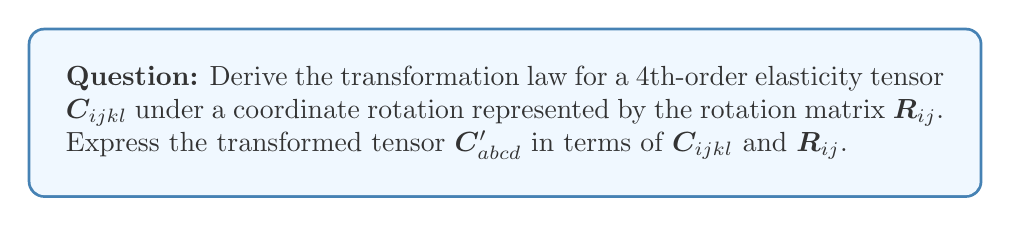What is the answer to this math problem? Let's approach this step-by-step:

1) First, recall that for a 4th-order tensor, the transformation law involves four rotation matrices:

   $$C'_{abcd} = R_{ai}R_{bj}R_{ck}R_{dl}C_{ijkl}$$

2) This equation represents the transformation of each index of the tensor. Each $R$ matrix rotates one index.

3) The summation convention is implied here, meaning we sum over repeated indices (i, j, k, l in this case).

4) To understand this transformation, let's break it down:
   - $R_{ai}$ rotates the first index (i to a)
   - $R_{bj}$ rotates the second index (j to b)
   - $R_{ck}$ rotates the third index (k to c)
   - $R_{dl}$ rotates the fourth index (l to d)

5) The rotation matrix $R_{ij}$ is orthogonal, meaning its inverse is equal to its transpose:

   $$R_{ij}^{-1} = R_{ji}$$

6) This property ensures that the transformed tensor $C'_{abcd}$ maintains the symmetries of the original tensor $C_{ijkl}$.

7) The full expansion of this transformation would involve a quadruple sum:

   $$C'_{abcd} = \sum_{i=1}^3 \sum_{j=1}^3 \sum_{k=1}^3 \sum_{l=1}^3 R_{ai}R_{bj}R_{ck}R_{dl}C_{ijkl}$$

8) This transformation preserves the tensor's rank and the physical laws it represents, ensuring that the elasticity relationships remain valid in the rotated coordinate system.
Answer: $$C'_{abcd} = R_{ai}R_{bj}R_{ck}R_{dl}C_{ijkl}$$ 